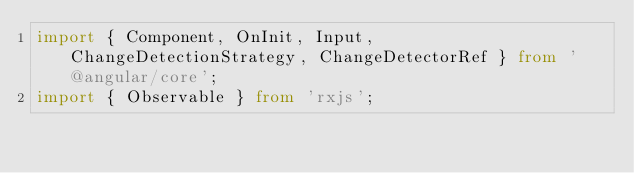<code> <loc_0><loc_0><loc_500><loc_500><_TypeScript_>import { Component, OnInit, Input, ChangeDetectionStrategy, ChangeDetectorRef } from '@angular/core';
import { Observable } from 'rxjs';</code> 